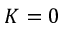Convert formula to latex. <formula><loc_0><loc_0><loc_500><loc_500>K = 0</formula> 